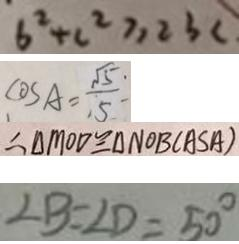Convert formula to latex. <formula><loc_0><loc_0><loc_500><loc_500>6 ^ { 2 } + c ^ { 2 } \geq 2 3 c 
 \cos A = \frac { \sqrt { 5 } } { 5 } 
 \therefore \Delta M O D \cong \Delta N O B ( A S A ) 
 \angle B = \angle D = 5 0 ^ { \circ }</formula> 